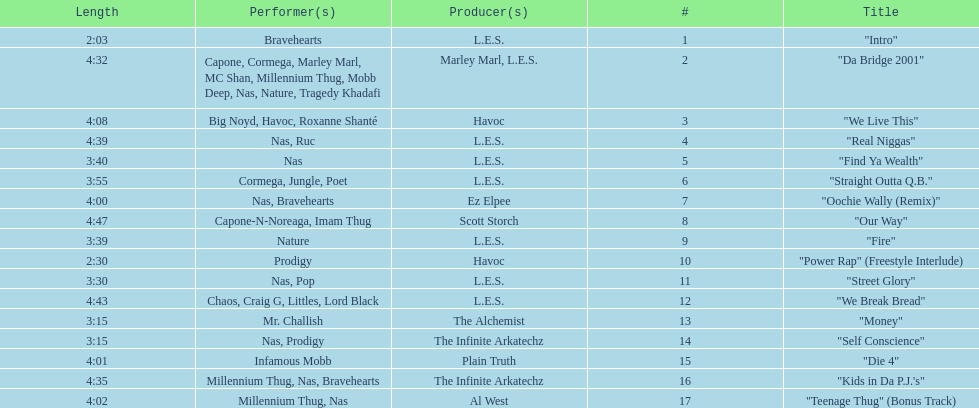What is the name of the last song on the album? "Teenage Thug" (Bonus Track). 